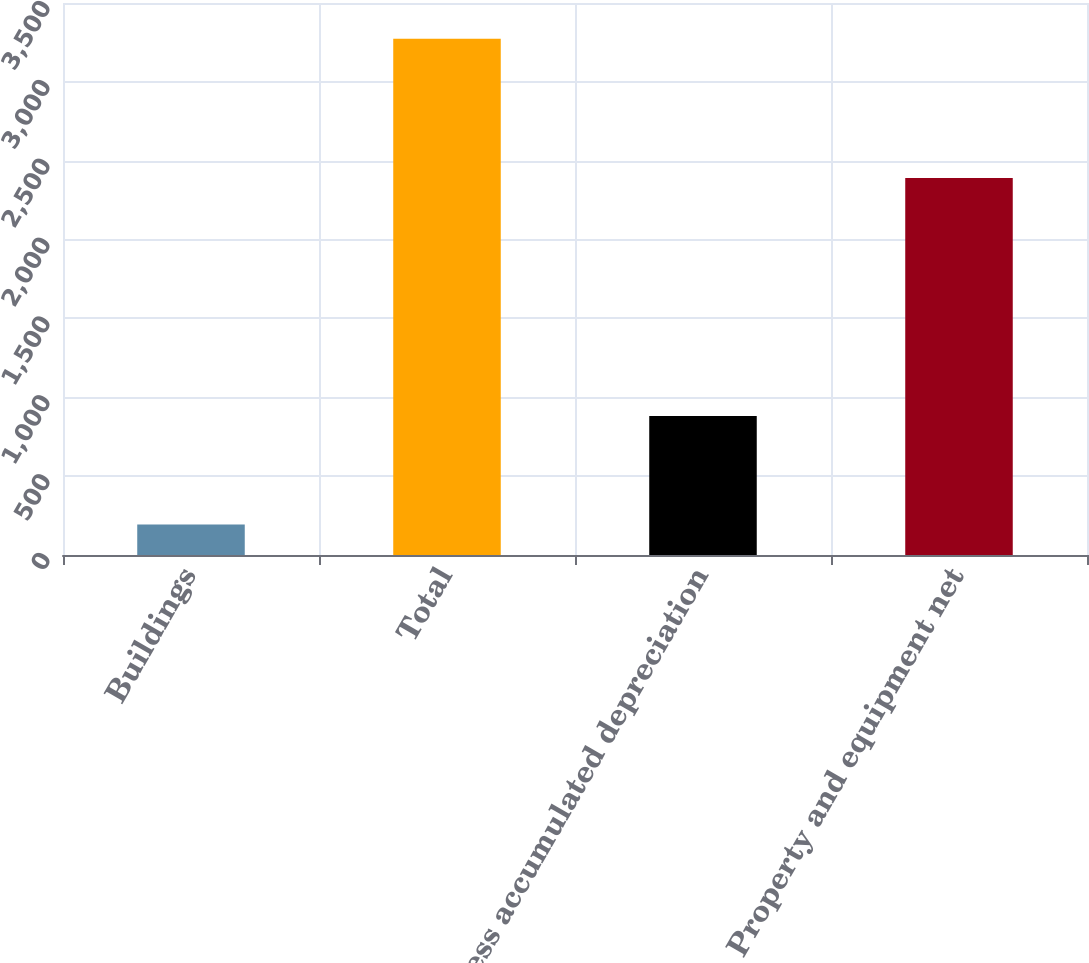<chart> <loc_0><loc_0><loc_500><loc_500><bar_chart><fcel>Buildings<fcel>Total<fcel>Less accumulated depreciation<fcel>Property and equipment net<nl><fcel>194<fcel>3273<fcel>882<fcel>2391<nl></chart> 